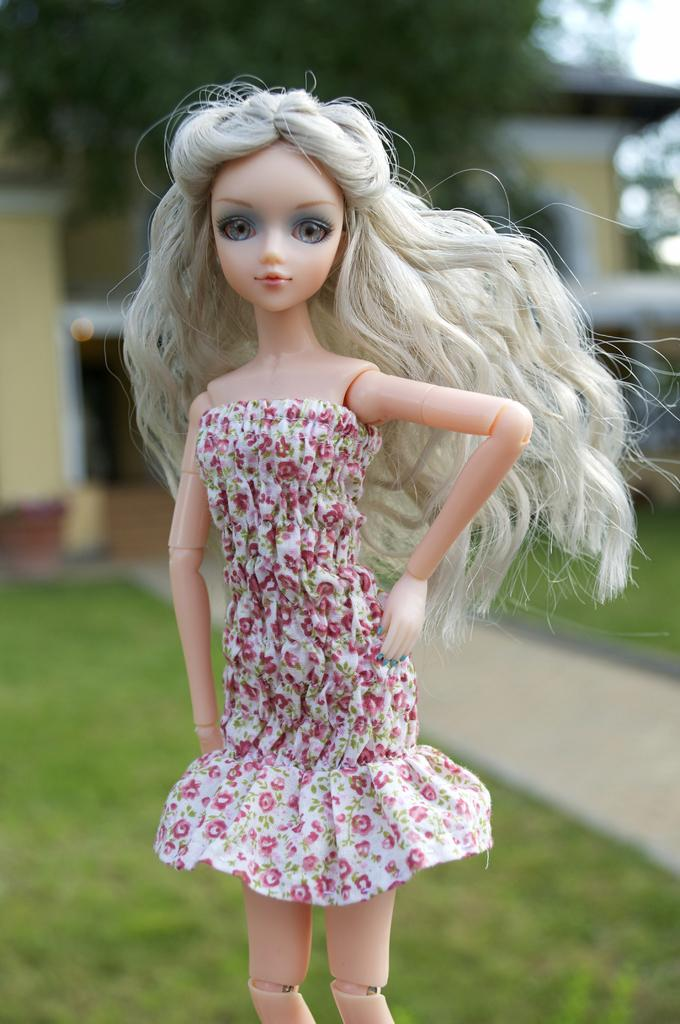What is the main subject in the image? There is a doll in the image. What type of natural environment is visible in the image? There is grass visible in the image. What type of structure can be seen in the image? There is a building in the image. What type of plant is present in the image? There is a tree in the image. What is visible in the background of the image? The sky is visible in the image. What type of book is the doll reading in the image? There is no book or reading activity depicted in the image; it features a doll and various other elements. 